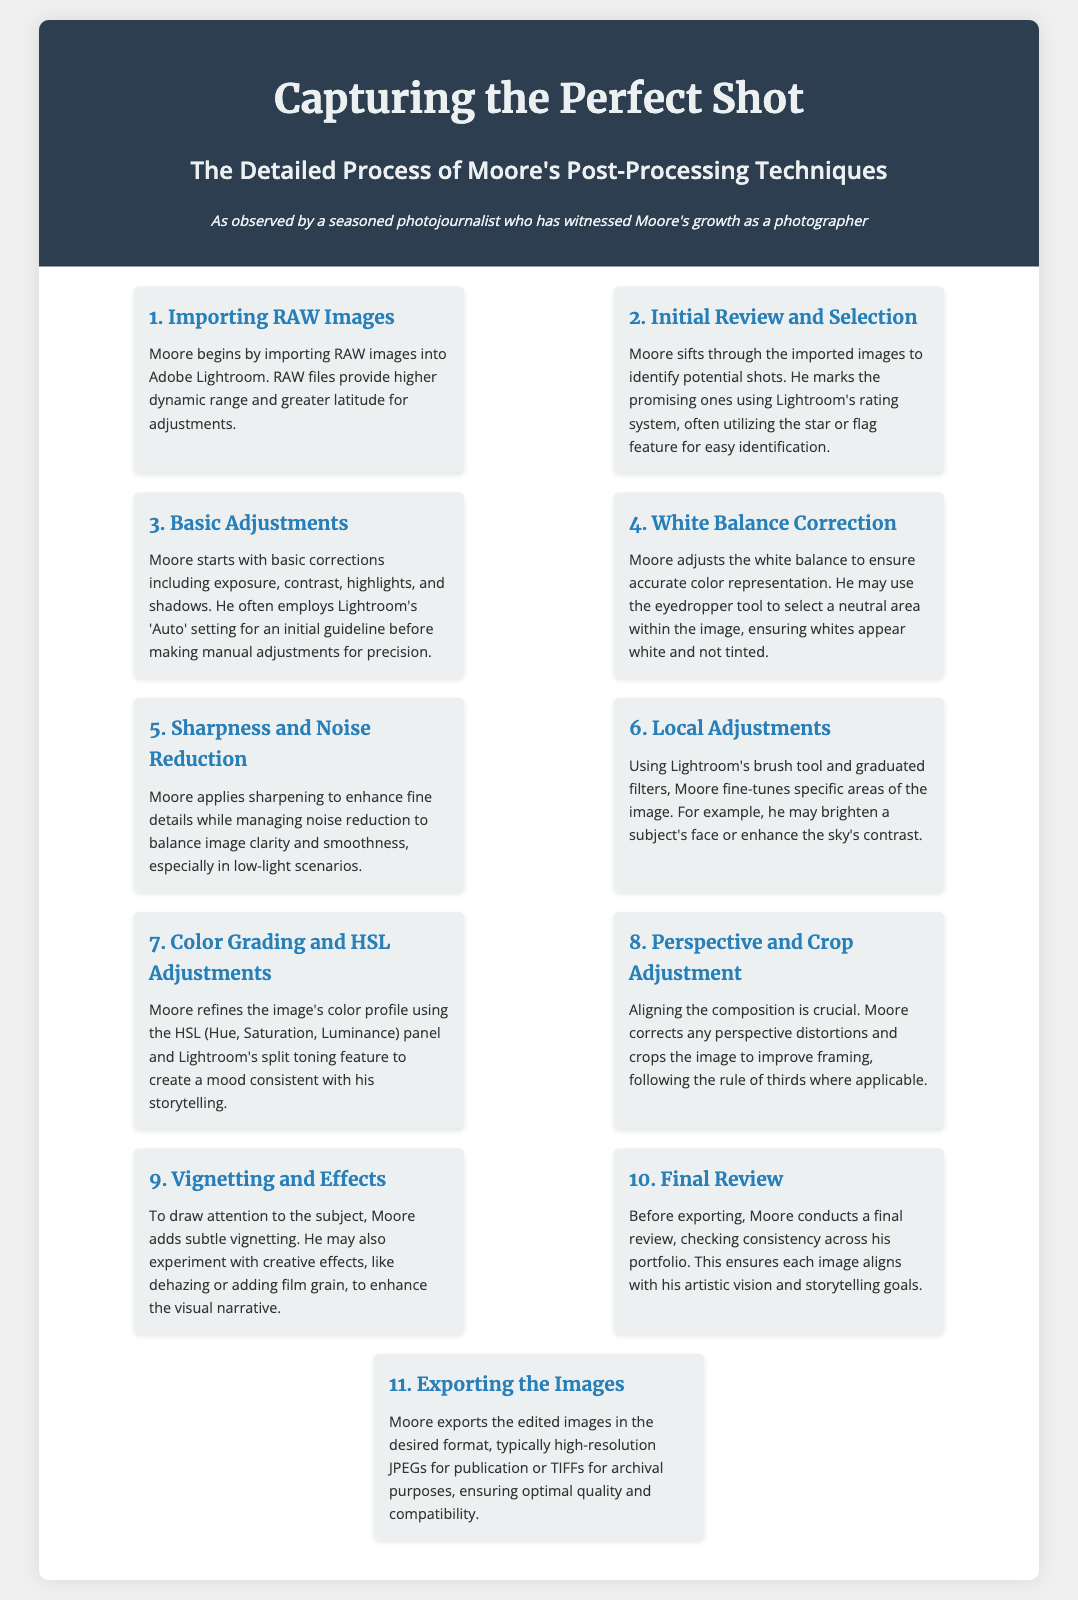what software does Moore use for post-processing? The document explicitly states that Moore begins by importing RAW images into Adobe Lightroom.
Answer: Adobe Lightroom what is the first step in Moore's post-processing process? The infographic outlines that the first step is importing RAW images.
Answer: Importing RAW Images how many steps are there in Moore's post-processing techniques? The document lists 11 distinct steps in Moore's post-processing techniques.
Answer: 11 what tool does Moore use to adjust white balance? The document mentions that he may use the eyedropper tool to select a neutral area within the image.
Answer: Eyedropper tool what is the purpose of local adjustments in Moore's process? The infographic states that local adjustments are used to fine-tune specific areas of the image, such as brightening a subject's face.
Answer: Fine-tune specific areas how does Moore ensure image clarity in low-light conditions? According to the document, Moore manages noise reduction to balance image clarity and smoothness in low-light scenarios.
Answer: Noise reduction what technique does Moore use to enhance color in his images? The document describes that Moore refines the image's color profile using the HSL (Hue, Saturation, Luminance) panel.
Answer: HSL panel what final step does Moore take before exporting? The infographic states that Moore conducts a final review to ensure consistency across his portfolio.
Answer: Final review 